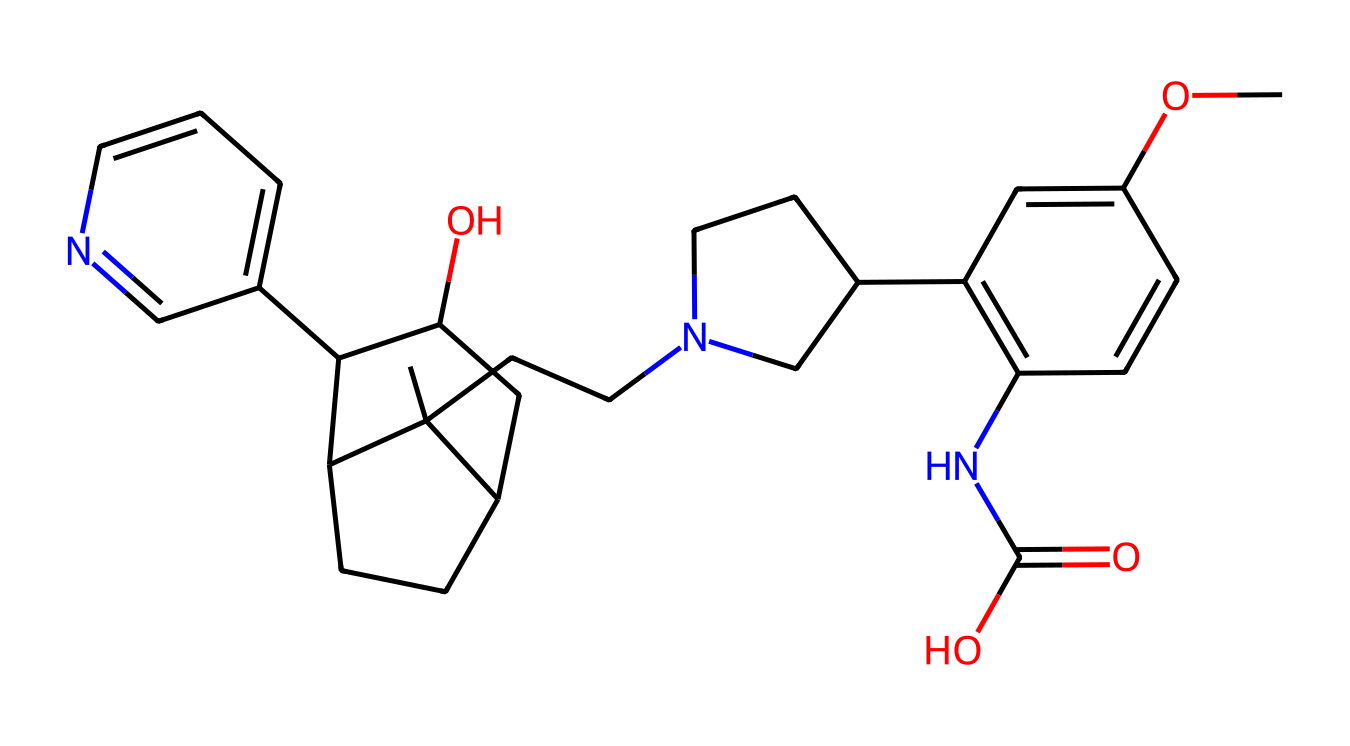What is the main functional group present in quinine? In the chemical structure provided, the presence of a nitrogen atom (N) suggests the presence of an amine group, common in alkaloids. Thus, quinine is characterized by the presence of an amine functional group.
Answer: amine How many nitrogen atoms are in this molecular structure? Scanning the structure, there are 2 distinct nitrogen atoms visible in the representation of quinine. This indicates the presence of two nitrogen functionalities in the molecule.
Answer: 2 What type of ring system is present in quinine? The chemical structure includes multiple rings, primarily a fused bicyclic system, which is key to quinine's classification as an alkaloid due to its complex ring structure.
Answer: bicyclic Does quinine contain any hydroxyl (OH) groups? Yes, there is a hydroxy group (-OH) attached to the carbon in the structure. This functional group contributes to the solubility of quinine in water.
Answer: yes What is the stereochemistry at the chiral centers of quinine? By analyzing the molecule, there are several chiral centers, contributing to its stereochemical complexity. However, precise stereochemical configuration requires deeper analysis on specific carbon atoms.
Answer: multiple chiral centers Does quinine exhibit basic properties due to its structure? Yes, the presence of nitrogen in the form of an amine contributes to basic properties, characteristic of many alkaloids. This nitrogen can accept protons, indicating basicity.
Answer: yes What is the molecular formula of quinine? By analyzing the number of each atom from the chemical structure, the molecular formula can be calculated: C20H24N2O2. This represents the respective counts of carbon, hydrogen, nitrogen, and oxygen atoms.
Answer: C20H24N2O2 